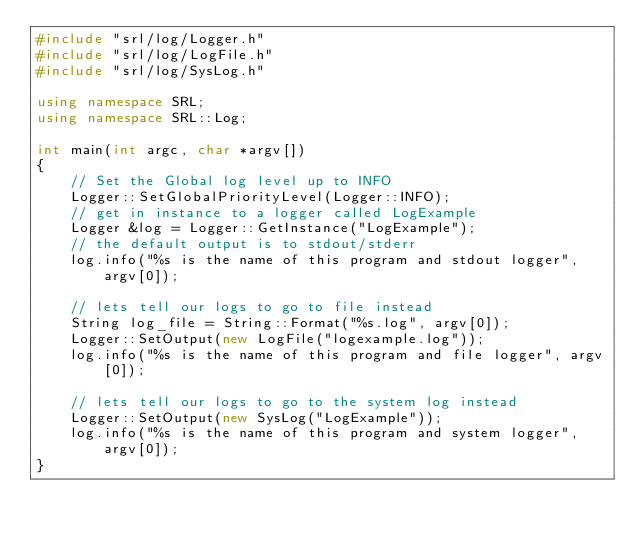Convert code to text. <code><loc_0><loc_0><loc_500><loc_500><_C++_>#include "srl/log/Logger.h"
#include "srl/log/LogFile.h"
#include "srl/log/SysLog.h"

using namespace SRL;
using namespace SRL::Log;

int main(int argc, char *argv[])
{
    // Set the Global log level up to INFO
    Logger::SetGlobalPriorityLevel(Logger::INFO);
    // get in instance to a logger called LogExample
    Logger &log = Logger::GetInstance("LogExample");
    // the default output is to stdout/stderr
    log.info("%s is the name of this program and stdout logger", argv[0]);

    // lets tell our logs to go to file instead
    String log_file = String::Format("%s.log", argv[0]);
    Logger::SetOutput(new LogFile("logexample.log"));
    log.info("%s is the name of this program and file logger", argv[0]);
    
    // lets tell our logs to go to the system log instead
    Logger::SetOutput(new SysLog("LogExample"));
    log.info("%s is the name of this program and system logger", argv[0]);
}
</code> 